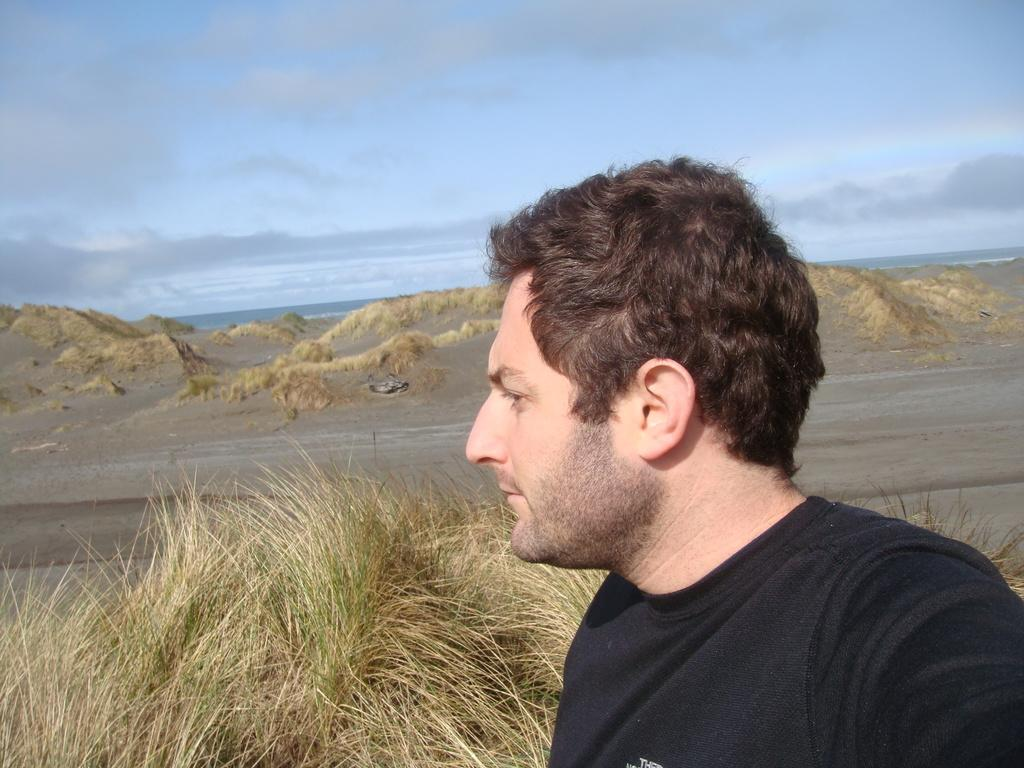What is the person in the image wearing? The person in the image is wearing a black dress. What can be seen in the background of the image? There is dry grass and mountains visible in the background. What is the color of the sky in the image? The sky is blue and white in color. Can you see a bird using a quill to write a message in the image? There is no bird or quill present in the image. 